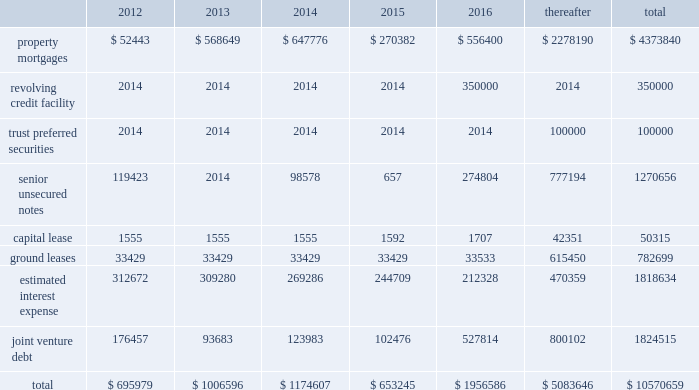56 / 57 management 2019s discussion and analysis of financial condition and results of operations junior subordinate deferrable interest debentures in june 2005 , we issued $ 100.0 a0million of trust preferred securities , which are reflected on the balance sheet as junior subordinate deferrable interest debentures .
The proceeds were used to repay our revolving credit facility .
The $ 100.0 a0million of junior subordi- nate deferrable interest debentures have a 30-year term ending july 2035 .
They bear interest at a fixed rate of 5.61% ( 5.61 % ) for the first 10 years ending july 2015 .
Thereafter , the rate will float at three month libor plus 1.25% ( 1.25 % ) .
The securities are redeemable at par .
Restrictive covenants the terms of the 2011 revolving credit facility and certain of our senior unsecured notes include certain restrictions and covenants which may limit , among other things , our ability to pay dividends ( as discussed below ) , make certain types of investments , incur additional indebtedness , incur liens and enter into negative pledge agreements and the disposition of assets , and which require compliance with financial ratios including our minimum tangible net worth , a maximum ratio of total indebtedness to total asset value , a minimum ratio of ebitda to fixed charges and a maximum ratio of unsecured indebtedness to unencumbered asset value .
The dividend restriction referred to above provides that we will not during any time when we are in default , make distributions with respect to common stock or other equity interests , except to enable us to continue to qualify as a reit for federal income tax purposes .
As of december a031 , 2011 and 2010 , we were in compli- ance with all such covenants .
Market rate risk we are exposed to changes in interest rates primarily from our floating rate borrowing arrangements .
We use interest rate deriv- ative instruments to manage exposure to interest rate changes .
A a0hypothetical 100 a0basis point increase in interest rates along the entire interest rate curve for 2011 and 2010 , would increase our annual interest cost by approximately $ 12.3 a0million and $ 11.0 a0mil- lion and would increase our share of joint venture annual interest cost by approximately $ 4.8 a0million and $ 6.7 a0million , respectively .
We recognize all derivatives on the balance sheet at fair value .
Derivatives that are not hedges must be adjusted to fair value through income .
If a derivative is a hedge , depending on the nature of the hedge , changes in the fair value of the derivative will either be offset against the change in fair value of the hedged asset , liability , or firm commitment through earnings , or recognized in other comprehensive income until the hedged item is recognized in earnings .
The ineffective portion of a derivative 2019s change in fair value is recognized immediately in earnings .
Approximately $ 4.8 a0billion of our long- term debt bore interest a0at fixed rates , and therefore the fair value of these instru- ments is affected by changes in the market interest rates .
The interest rate on our variable rate debt and joint venture debt as of december a031 , 2011 ranged from libor plus 150 a0basis points to libor plus 350 a0basis points .
Contractual obligations combined aggregate principal maturities of mortgages and other loans payable , our 2011 revolving credit facility , senior unsecured notes ( net of discount ) , trust preferred securities , our share of joint venture debt , including as- of-right extension options , estimated interest expense ( based on weighted average interest rates for the quarter ) , and our obligations under our capital lease and ground leases , as of december a031 , 2011 are as follows ( in thousands ) : .

By how much does the total joint venture debt from 2012-2016 exceed the joint venture debt after 2016? 
Rationale: add all years from 2012:2016 and then subtract the "thereafter" number
Computations: (((((176457 + 93683) + 123983) + 102476) + 527814) - 800102)
Answer: 224311.0. 56 / 57 management 2019s discussion and analysis of financial condition and results of operations junior subordinate deferrable interest debentures in june 2005 , we issued $ 100.0 a0million of trust preferred securities , which are reflected on the balance sheet as junior subordinate deferrable interest debentures .
The proceeds were used to repay our revolving credit facility .
The $ 100.0 a0million of junior subordi- nate deferrable interest debentures have a 30-year term ending july 2035 .
They bear interest at a fixed rate of 5.61% ( 5.61 % ) for the first 10 years ending july 2015 .
Thereafter , the rate will float at three month libor plus 1.25% ( 1.25 % ) .
The securities are redeemable at par .
Restrictive covenants the terms of the 2011 revolving credit facility and certain of our senior unsecured notes include certain restrictions and covenants which may limit , among other things , our ability to pay dividends ( as discussed below ) , make certain types of investments , incur additional indebtedness , incur liens and enter into negative pledge agreements and the disposition of assets , and which require compliance with financial ratios including our minimum tangible net worth , a maximum ratio of total indebtedness to total asset value , a minimum ratio of ebitda to fixed charges and a maximum ratio of unsecured indebtedness to unencumbered asset value .
The dividend restriction referred to above provides that we will not during any time when we are in default , make distributions with respect to common stock or other equity interests , except to enable us to continue to qualify as a reit for federal income tax purposes .
As of december a031 , 2011 and 2010 , we were in compli- ance with all such covenants .
Market rate risk we are exposed to changes in interest rates primarily from our floating rate borrowing arrangements .
We use interest rate deriv- ative instruments to manage exposure to interest rate changes .
A a0hypothetical 100 a0basis point increase in interest rates along the entire interest rate curve for 2011 and 2010 , would increase our annual interest cost by approximately $ 12.3 a0million and $ 11.0 a0mil- lion and would increase our share of joint venture annual interest cost by approximately $ 4.8 a0million and $ 6.7 a0million , respectively .
We recognize all derivatives on the balance sheet at fair value .
Derivatives that are not hedges must be adjusted to fair value through income .
If a derivative is a hedge , depending on the nature of the hedge , changes in the fair value of the derivative will either be offset against the change in fair value of the hedged asset , liability , or firm commitment through earnings , or recognized in other comprehensive income until the hedged item is recognized in earnings .
The ineffective portion of a derivative 2019s change in fair value is recognized immediately in earnings .
Approximately $ 4.8 a0billion of our long- term debt bore interest a0at fixed rates , and therefore the fair value of these instru- ments is affected by changes in the market interest rates .
The interest rate on our variable rate debt and joint venture debt as of december a031 , 2011 ranged from libor plus 150 a0basis points to libor plus 350 a0basis points .
Contractual obligations combined aggregate principal maturities of mortgages and other loans payable , our 2011 revolving credit facility , senior unsecured notes ( net of discount ) , trust preferred securities , our share of joint venture debt , including as- of-right extension options , estimated interest expense ( based on weighted average interest rates for the quarter ) , and our obligations under our capital lease and ground leases , as of december a031 , 2011 are as follows ( in thousands ) : .

A hypothetical 100 basis point increase in interest rates along the entire interest rate curve for 2011 and 2010 would increase our annual interest cost by what average amount , in millions? 
Computations: ((12.3 + 11.0) / 2)
Answer: 11.65. 